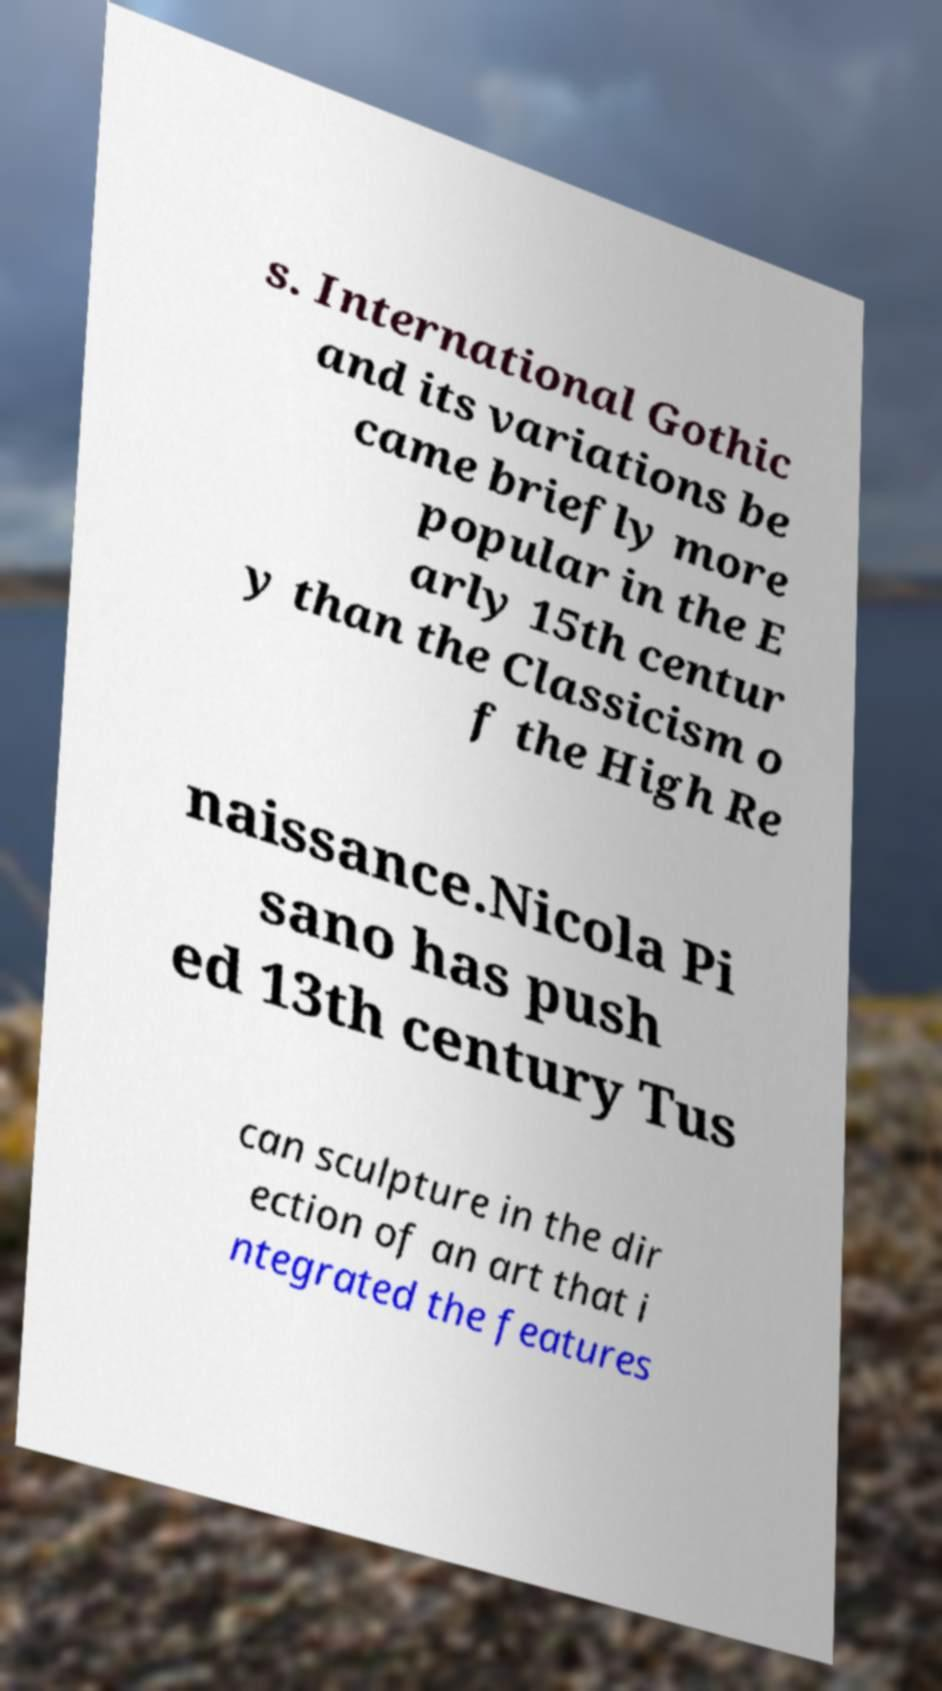Please read and relay the text visible in this image. What does it say? s. International Gothic and its variations be came briefly more popular in the E arly 15th centur y than the Classicism o f the High Re naissance.Nicola Pi sano has push ed 13th century Tus can sculpture in the dir ection of an art that i ntegrated the features 